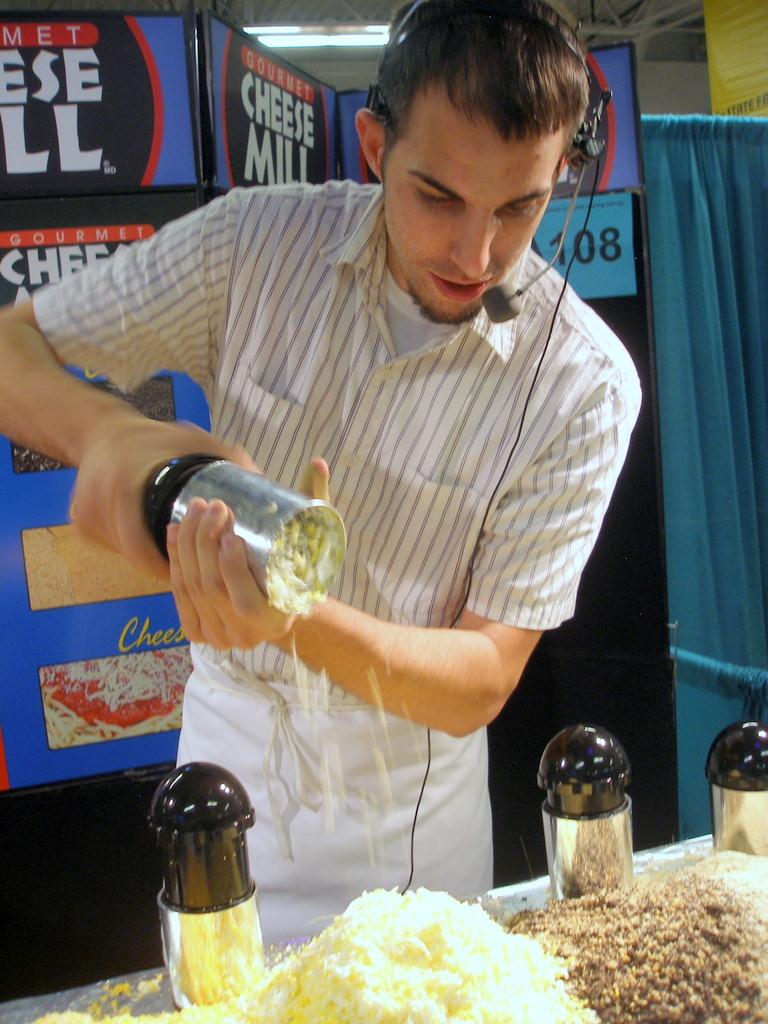What kind of mill?
Provide a short and direct response. Cheese. 